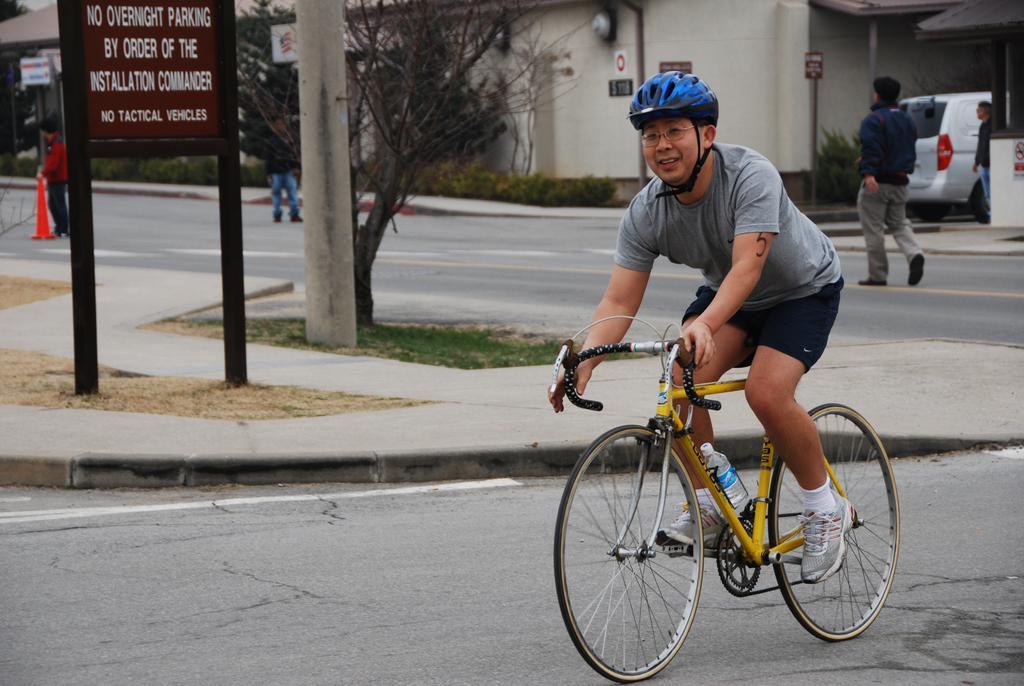How would you summarize this image in a sentence or two? In this picture there is a man riding a bicycle, He is wearing a grey shirt, black short and blue helmet. Towards the left there is a board and some text on it. In the center there is a tree. Towards the right top there are two people and a vehicle. In the background there is a building. 